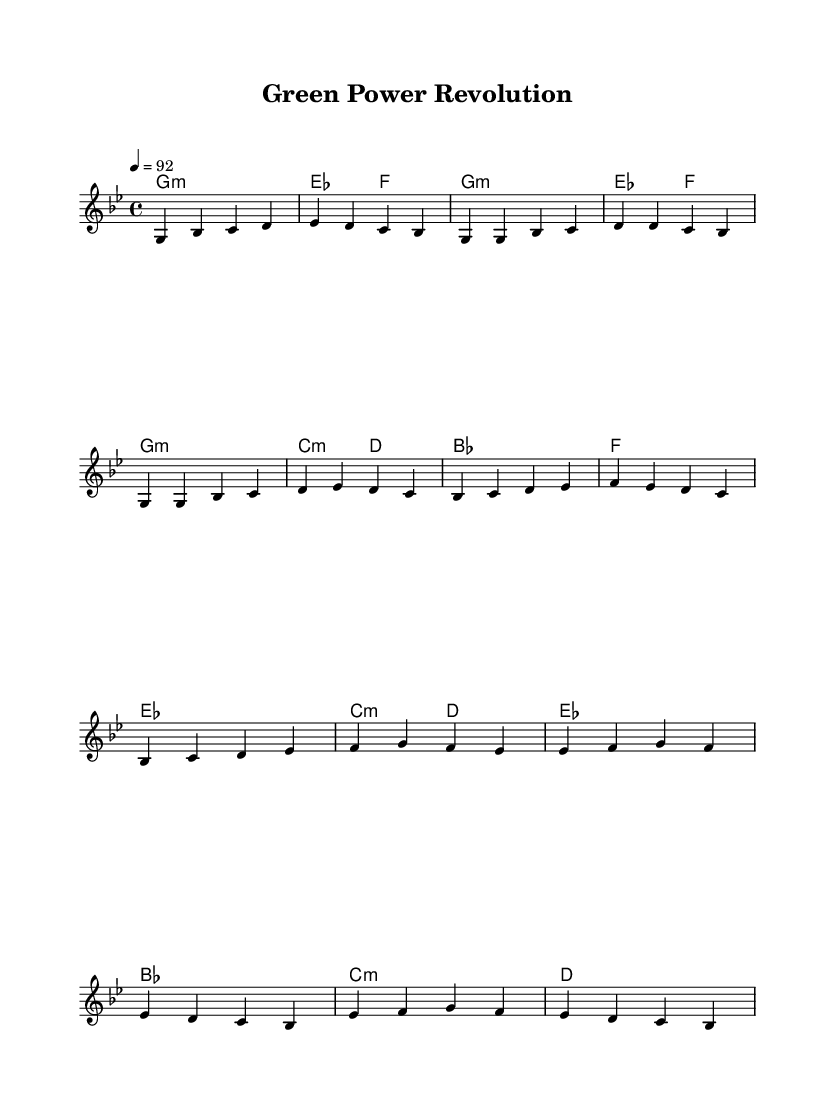What is the key signature of this music? The key signature is indicated by the key signature symbols at the beginning of the staff. Here, the key signature shows one flat (B♭), which defines the piece as being in G minor.
Answer: G minor What is the time signature of this music? The time signature is found after the key signature and is shown as a fraction. In this case, it is 4 over 4, which indicates a four-beat measure with a quarter note receiving one beat.
Answer: 4/4 What is the tempo marking for this piece? The tempo marking is displayed above the staff, stating "4 = 92". This indicates that there are 92 beats per minute and that a quarter note gets one beat.
Answer: 92 How many measures are in the verse section? The verse section consists of a sequence of melodies and chords. Counting each group of notes, there are four measures listed in the verse.
Answer: 4 What is the main theme of the lyrics as suggested by the title? The title "Green Power Revolution" implies a focus on sustainability and renewable energy, suggesting that the lyrics will revolve around breakthroughs in green technology and sustainable practices.
Answer: Renewable energy How many different sections are present in this composition? The composition contains four distinct sections: Intro, Verse, Chorus, and Bridge. Each section serves a specific role in the structure of the piece.
Answer: 4 What type of musical genre is this sheet music representative of? The characteristics of the rhythms, the structure, and lyric focus on urban themes confirm that this is a hip hop genre intended for delivering messages related to social themes, specifically sustainability.
Answer: Hip Hop 